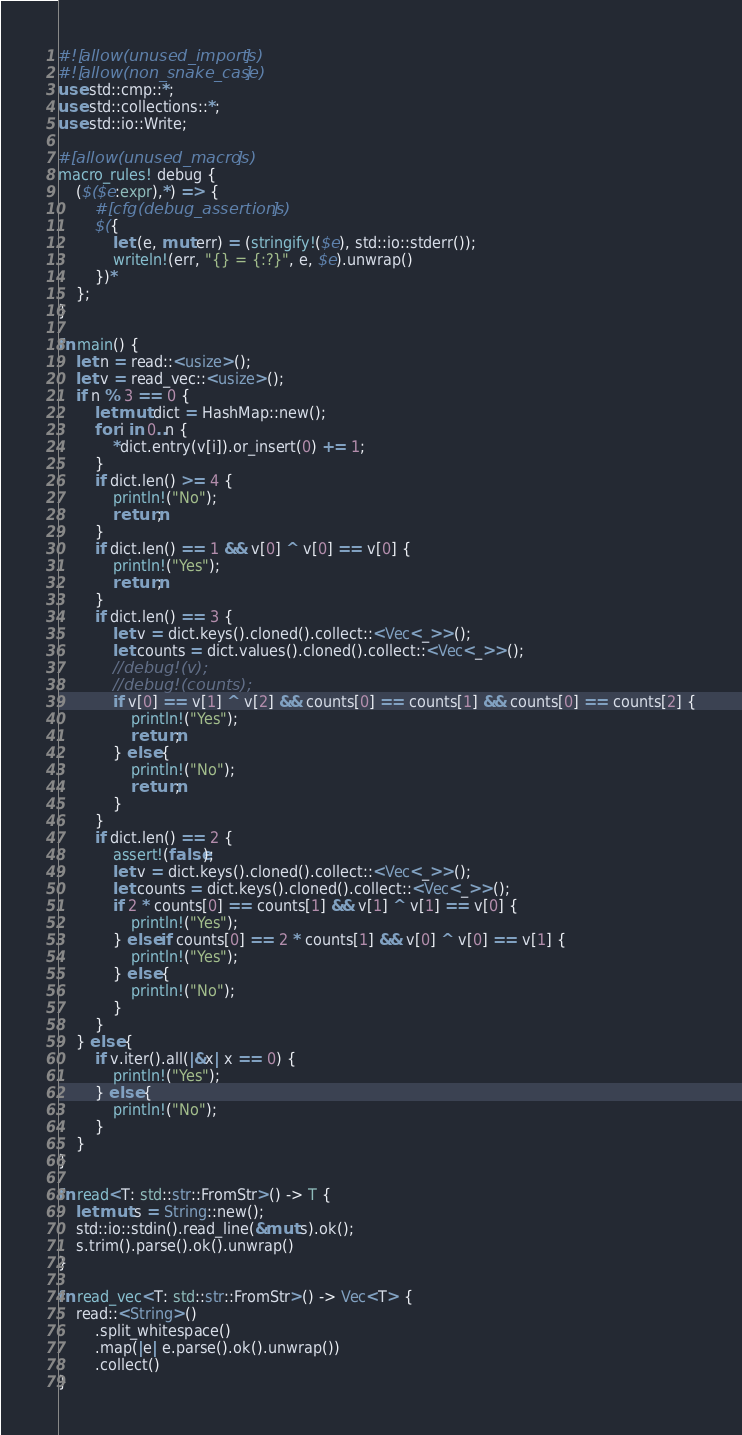Convert code to text. <code><loc_0><loc_0><loc_500><loc_500><_Rust_>#![allow(unused_imports)]
#![allow(non_snake_case)]
use std::cmp::*;
use std::collections::*;
use std::io::Write;

#[allow(unused_macros)]
macro_rules! debug {
    ($($e:expr),*) => {
        #[cfg(debug_assertions)]
        $({
            let (e, mut err) = (stringify!($e), std::io::stderr());
            writeln!(err, "{} = {:?}", e, $e).unwrap()
        })*
    };
}

fn main() {
    let n = read::<usize>();
    let v = read_vec::<usize>();
    if n % 3 == 0 {
        let mut dict = HashMap::new();
        for i in 0..n {
            *dict.entry(v[i]).or_insert(0) += 1;
        }
        if dict.len() >= 4 {
            println!("No");
            return;
        }
        if dict.len() == 1 && v[0] ^ v[0] == v[0] {
            println!("Yes");
            return;
        }
        if dict.len() == 3 {
            let v = dict.keys().cloned().collect::<Vec<_>>();
            let counts = dict.values().cloned().collect::<Vec<_>>();
            //debug!(v);
            //debug!(counts);
            if v[0] == v[1] ^ v[2] && counts[0] == counts[1] && counts[0] == counts[2] {
                println!("Yes");
                return;
            } else {
                println!("No");
                return;
            }
        }
        if dict.len() == 2 {
            assert!(false);
            let v = dict.keys().cloned().collect::<Vec<_>>();
            let counts = dict.keys().cloned().collect::<Vec<_>>();
            if 2 * counts[0] == counts[1] && v[1] ^ v[1] == v[0] {
                println!("Yes");
            } else if counts[0] == 2 * counts[1] && v[0] ^ v[0] == v[1] {
                println!("Yes");
            } else {
                println!("No");
            }
        }
    } else {
        if v.iter().all(|&x| x == 0) {
            println!("Yes");
        } else {
            println!("No");
        }
    }
}

fn read<T: std::str::FromStr>() -> T {
    let mut s = String::new();
    std::io::stdin().read_line(&mut s).ok();
    s.trim().parse().ok().unwrap()
}

fn read_vec<T: std::str::FromStr>() -> Vec<T> {
    read::<String>()
        .split_whitespace()
        .map(|e| e.parse().ok().unwrap())
        .collect()
}
</code> 